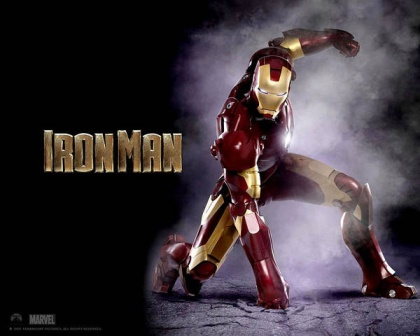What kinds of technologies might be integrated into Iron Man's suit to make it so advanced? Iron Man's suit is the pinnacle of advanced technology. It could include a variety of high-end features such as a powerful arc reactor for sustainable energy, advanced AI to assist with targeting and battle strategies, and an array of onboard weaponry like repulsor blasts and missiles. The suit might also have a flight system integrating jet propulsion and stabilizers, as well as a sophisticated communication array linking Iron Man to global networks and allies. Integrated defense systems, like force fields or sonic repulsion, as well as self-repair mechanisms and advanced materials for durability and flexibility, could also be key components. 